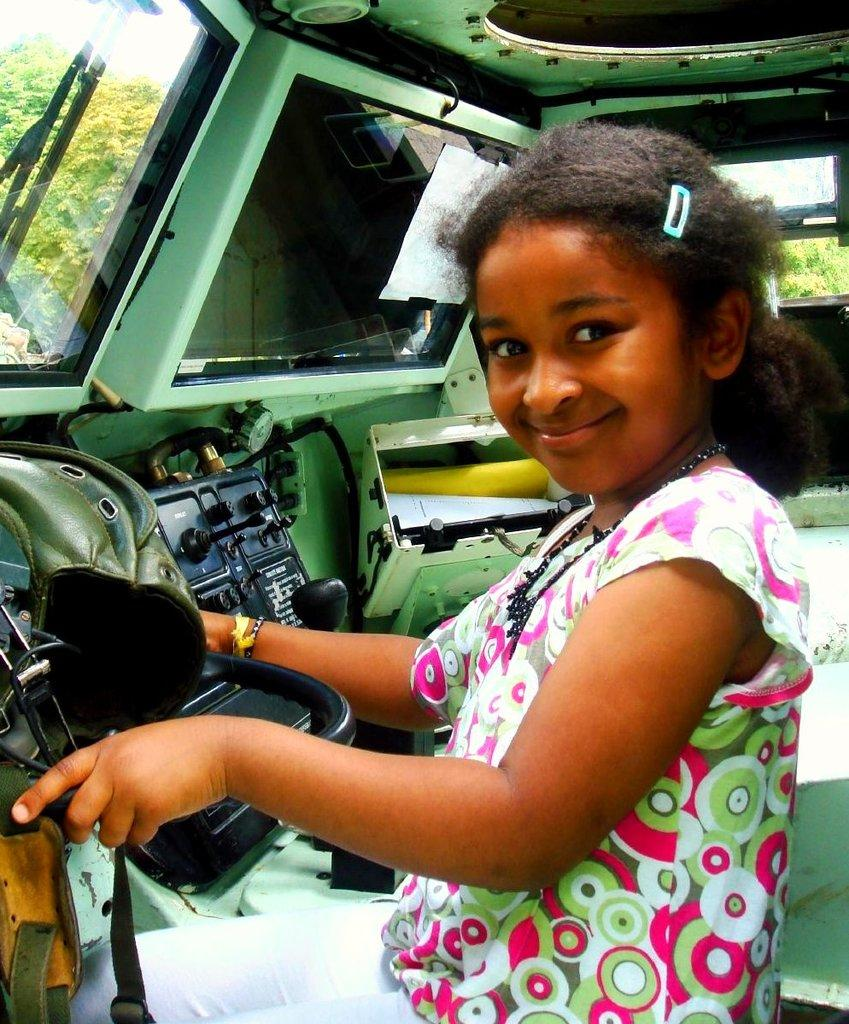Who is the main subject in the image? There is a girl in the image. What is the girl wearing? The girl is wearing a white pant and top. Where is the girl located in the image? The girl is sitting inside a vehicle. What is the girl holding in the image? The girl is holding an object. What is the girl doing in the image? The girl is posing for a photo. What can be seen in the background of the image? There are trees in the background of the image. What type of badge is the girl wearing in the image? There is no badge visible on the girl in the image. What color is the paint on the vehicle the girl is sitting in? The provided facts do not mention the color of the vehicle or any paint on it. 